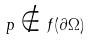<formula> <loc_0><loc_0><loc_500><loc_500>p \notin f ( \partial \Omega )</formula> 